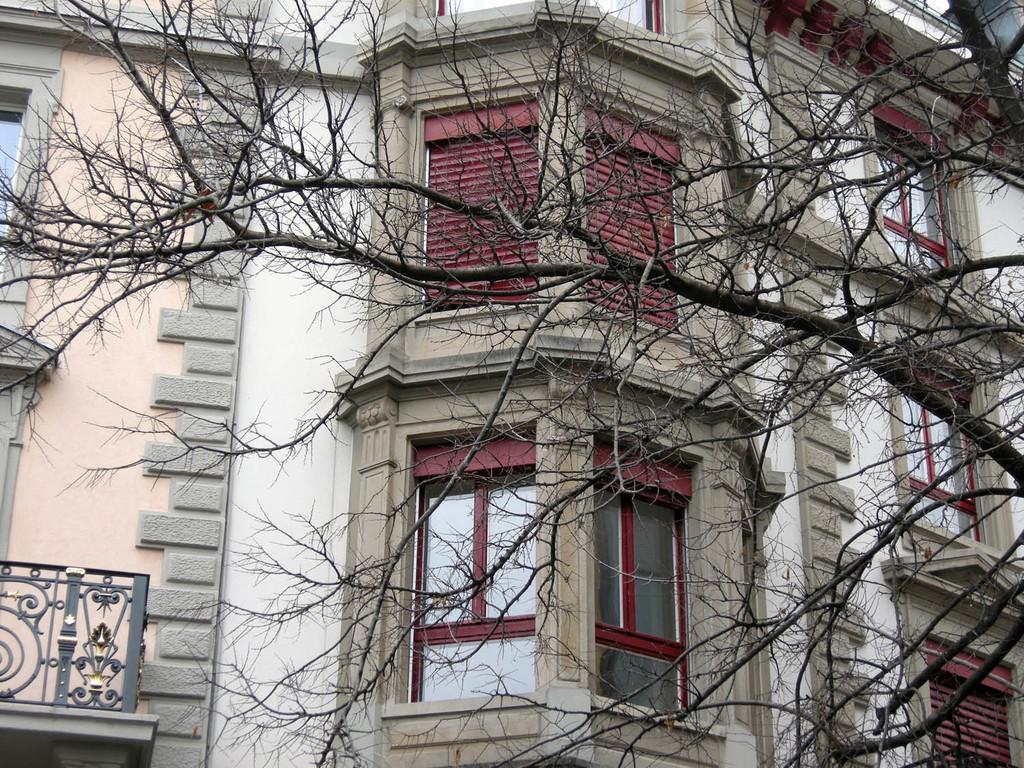Could you give a brief overview of what you see in this image? In the foreground of the picture there is a tree. In picture there is a building, we can see windows of the building. 